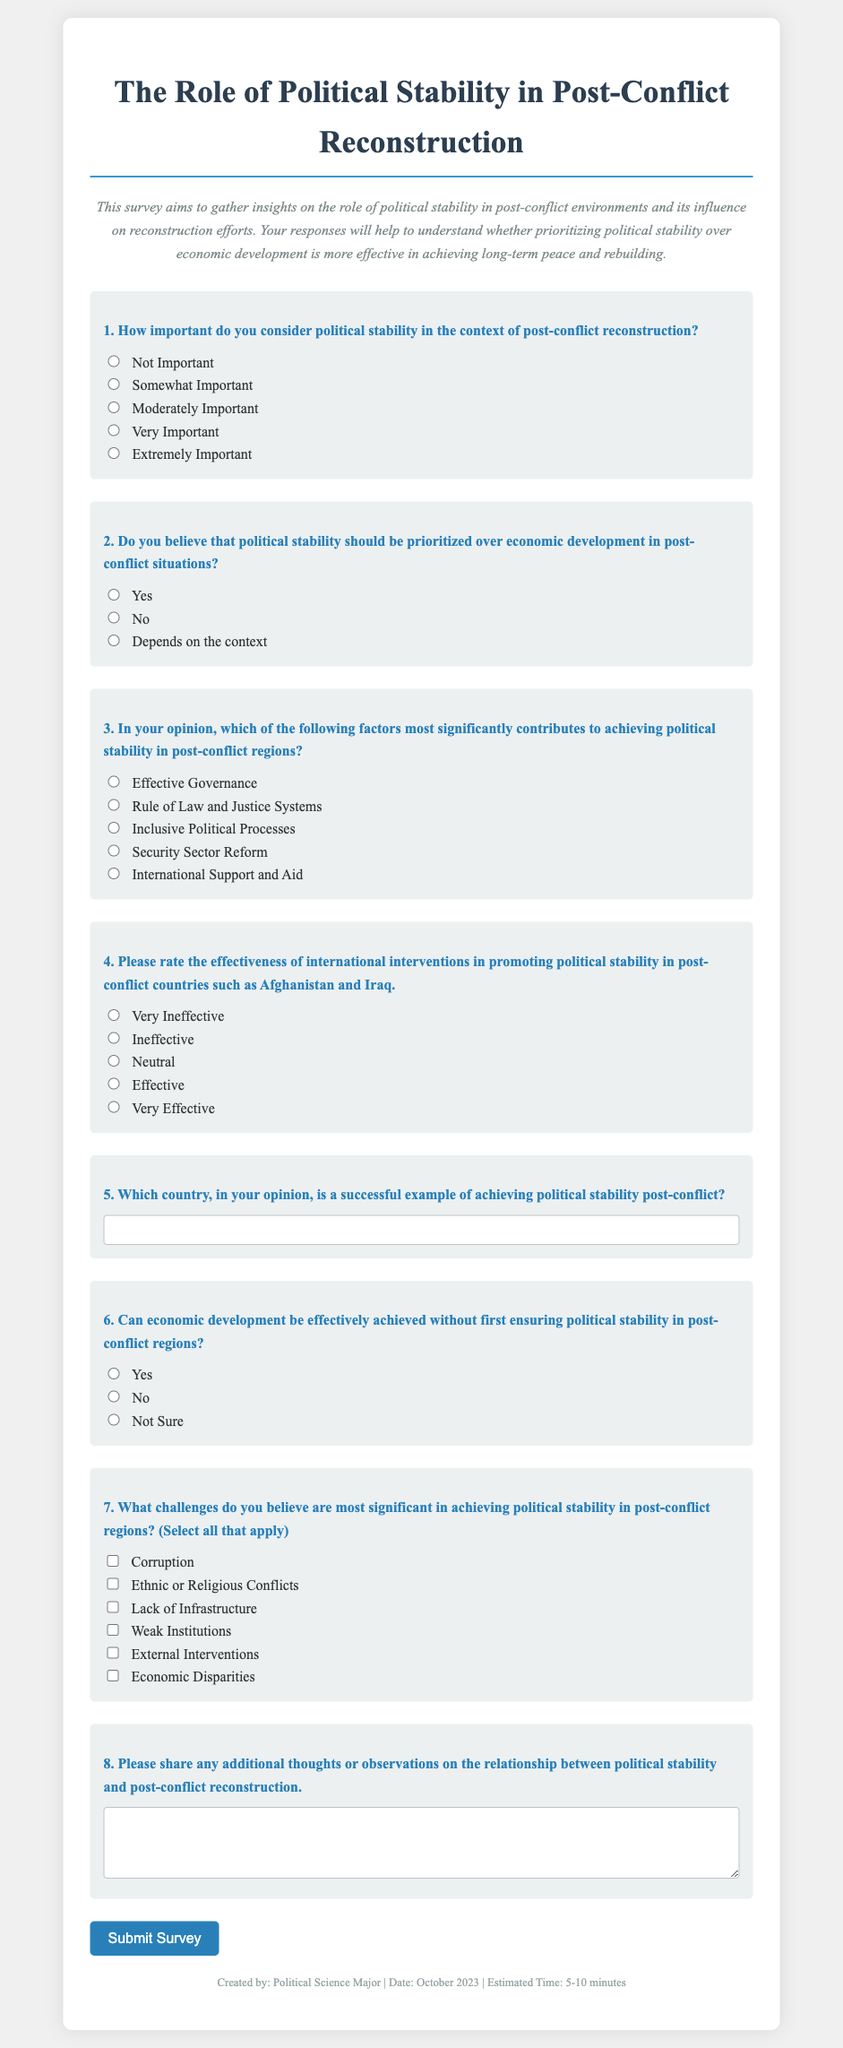What is the title of the survey? The title of the survey is presented prominently at the top of the document.
Answer: The Role of Political Stability in Post-Conflict Reconstruction How many questions are in the survey? By counting the number of distinct questions listed in the survey form, we can determine the total.
Answer: 8 What is the first question about? The content of the first question focuses on the importance of political stability post-conflict.
Answer: Importance of political stability What type of response does question 5 request? Question 5 specifically asks for a type of information that requires a subjective opinion on successful examples.
Answer: Short answer What is the effective governance option in question 3? The responses in question 3 include various factors contributing to political stability, one of which is effective governance.
Answer: Effective Governance Which option indicates disagreement with prioritizing political stability over economic development? The second question provides options that reflect opinions on the priority of political stability.
Answer: No Could you name one of the challenges listed in question 7? Question 7 allows respondents to select multiple answers regarding challenges, implying various issues.
Answer: Corruption What type of input does question 8 solicit? Question 8 is designed to gather broader insights rather than specific responses.
Answer: Additional thoughts or observations 